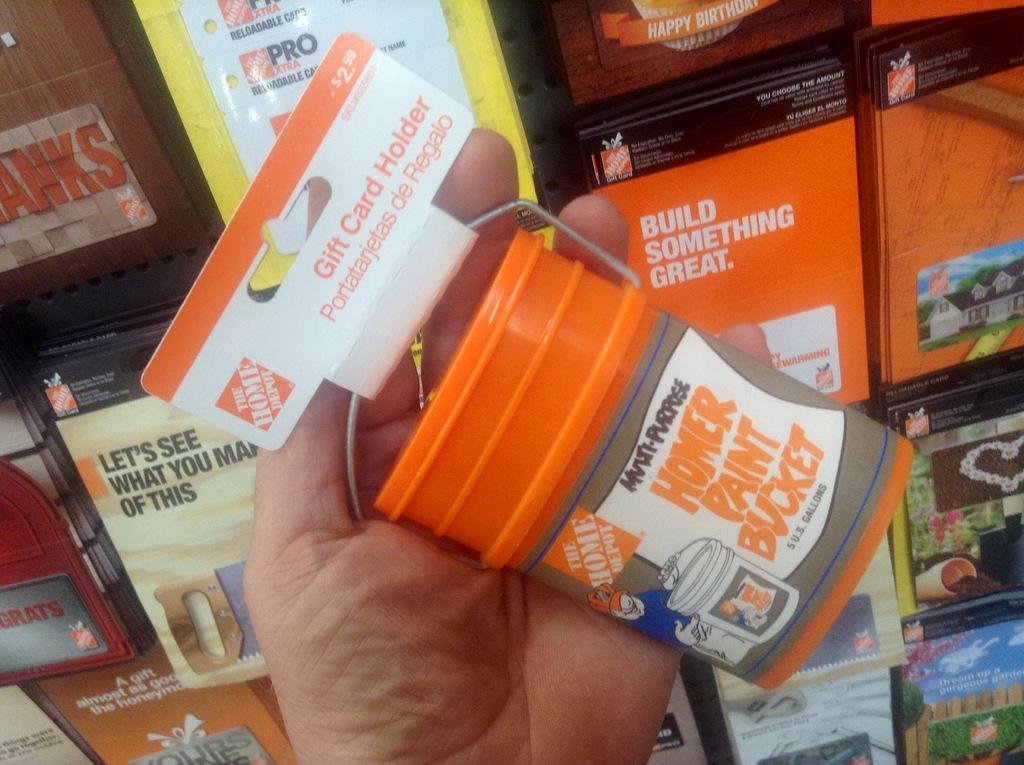<image>
Give a short and clear explanation of the subsequent image. A person holds a Home Depot gift card holder that looks like a bucket. 